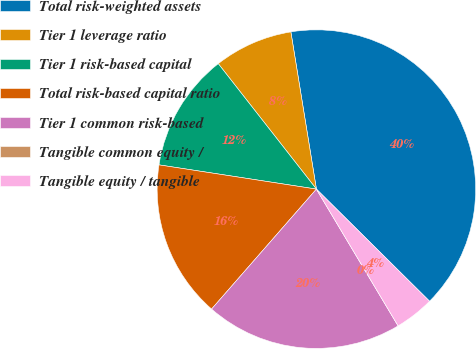<chart> <loc_0><loc_0><loc_500><loc_500><pie_chart><fcel>Total risk-weighted assets<fcel>Tier 1 leverage ratio<fcel>Tier 1 risk-based capital<fcel>Total risk-based capital ratio<fcel>Tier 1 common risk-based<fcel>Tangible common equity /<fcel>Tangible equity / tangible<nl><fcel>39.99%<fcel>8.0%<fcel>12.0%<fcel>16.0%<fcel>20.0%<fcel>0.0%<fcel>4.0%<nl></chart> 